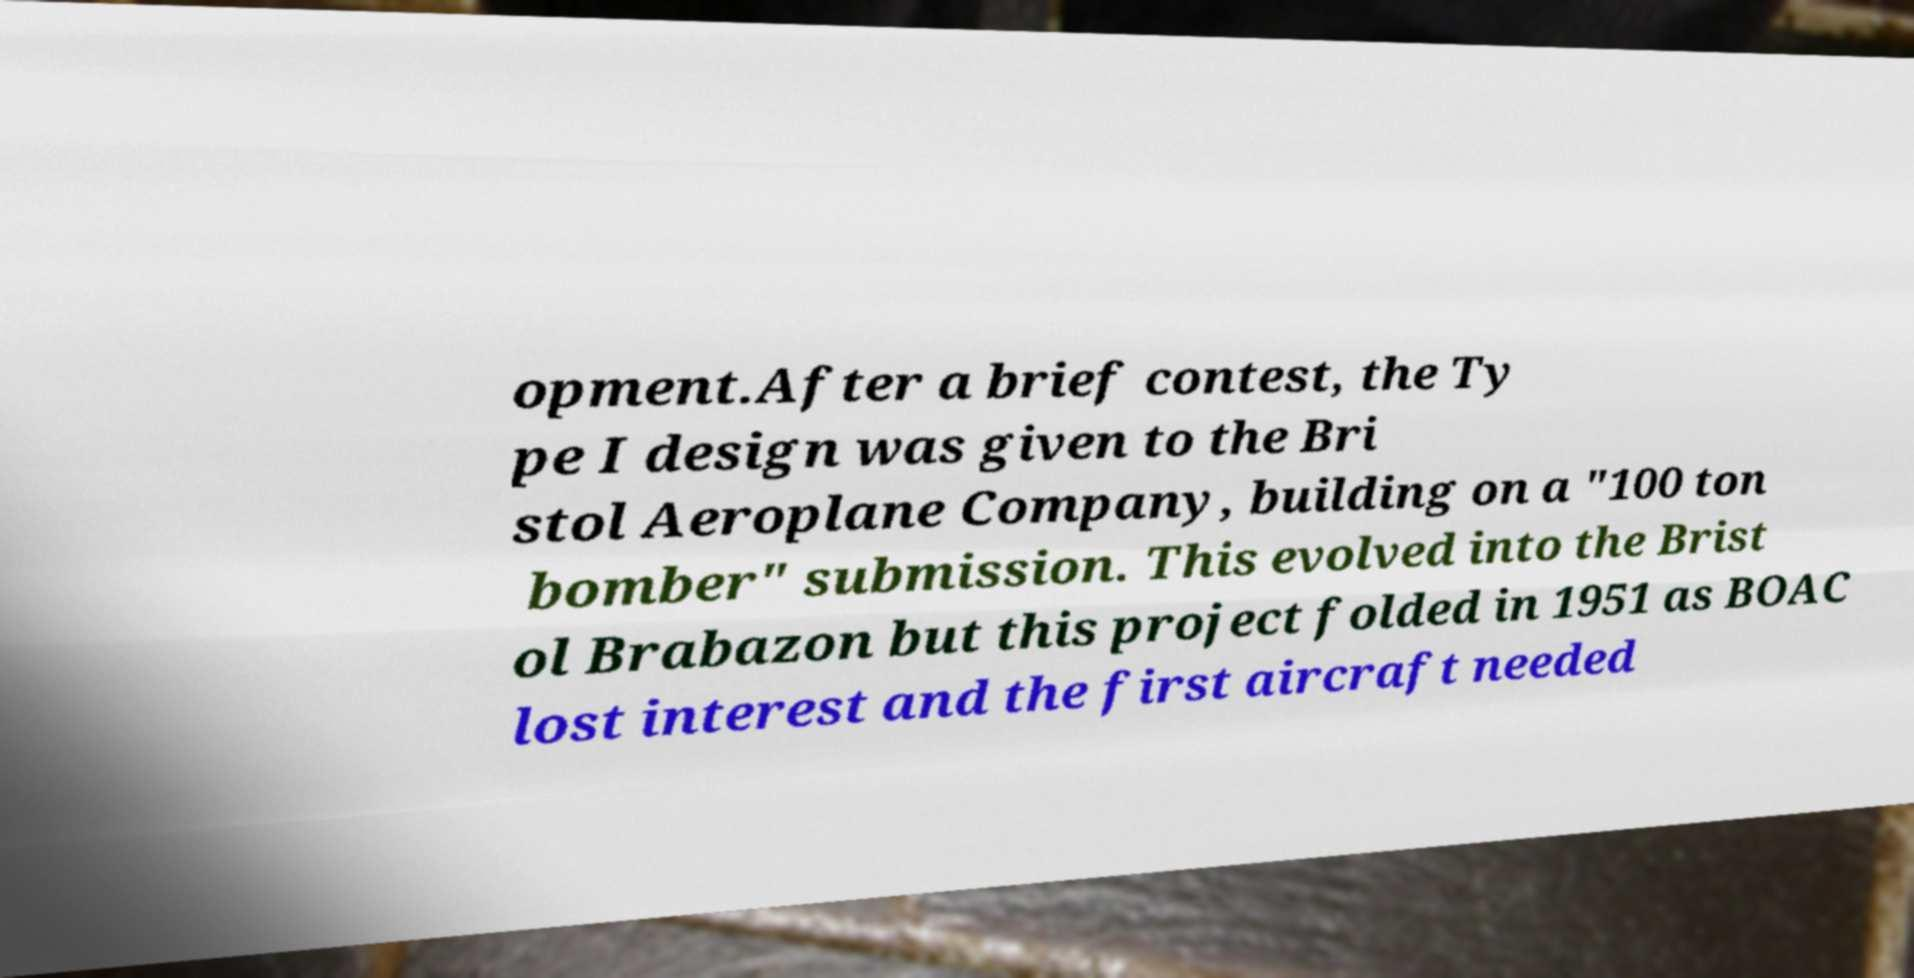Could you assist in decoding the text presented in this image and type it out clearly? opment.After a brief contest, the Ty pe I design was given to the Bri stol Aeroplane Company, building on a "100 ton bomber" submission. This evolved into the Brist ol Brabazon but this project folded in 1951 as BOAC lost interest and the first aircraft needed 